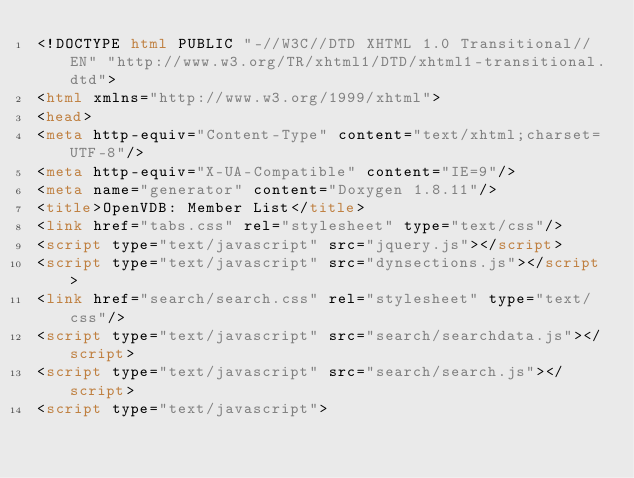<code> <loc_0><loc_0><loc_500><loc_500><_HTML_><!DOCTYPE html PUBLIC "-//W3C//DTD XHTML 1.0 Transitional//EN" "http://www.w3.org/TR/xhtml1/DTD/xhtml1-transitional.dtd">
<html xmlns="http://www.w3.org/1999/xhtml">
<head>
<meta http-equiv="Content-Type" content="text/xhtml;charset=UTF-8"/>
<meta http-equiv="X-UA-Compatible" content="IE=9"/>
<meta name="generator" content="Doxygen 1.8.11"/>
<title>OpenVDB: Member List</title>
<link href="tabs.css" rel="stylesheet" type="text/css"/>
<script type="text/javascript" src="jquery.js"></script>
<script type="text/javascript" src="dynsections.js"></script>
<link href="search/search.css" rel="stylesheet" type="text/css"/>
<script type="text/javascript" src="search/searchdata.js"></script>
<script type="text/javascript" src="search/search.js"></script>
<script type="text/javascript"></code> 